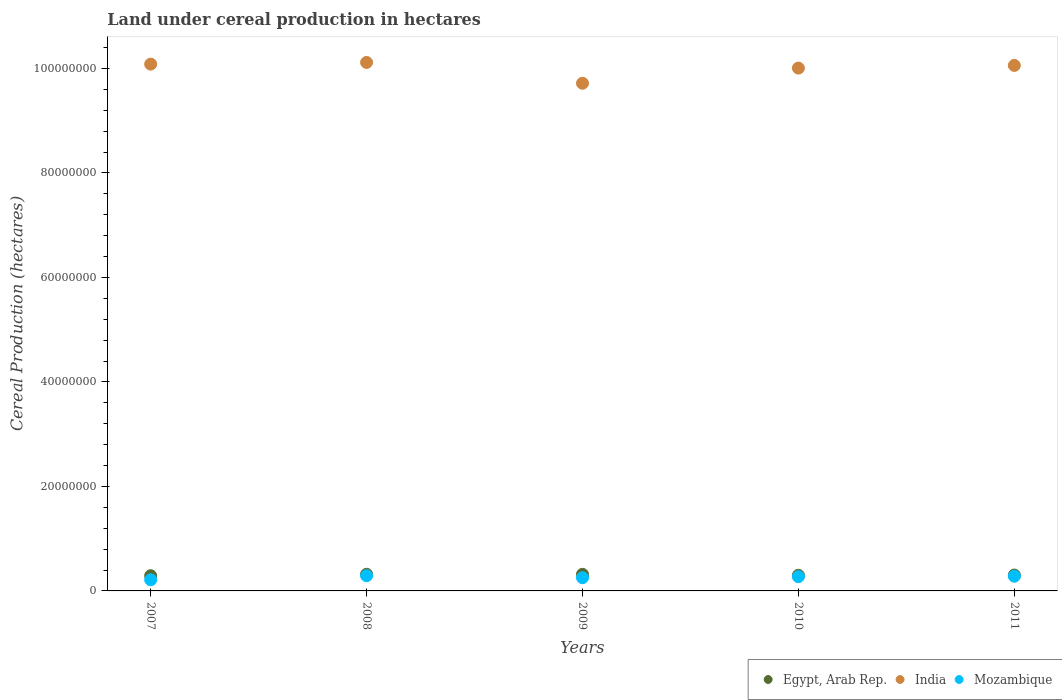What is the land under cereal production in Mozambique in 2008?
Provide a succinct answer. 2.91e+06. Across all years, what is the maximum land under cereal production in Egypt, Arab Rep.?
Offer a terse response. 3.19e+06. Across all years, what is the minimum land under cereal production in India?
Provide a succinct answer. 9.72e+07. In which year was the land under cereal production in India maximum?
Keep it short and to the point. 2008. What is the total land under cereal production in India in the graph?
Ensure brevity in your answer.  5.00e+08. What is the difference between the land under cereal production in Egypt, Arab Rep. in 2007 and that in 2008?
Provide a succinct answer. -2.74e+05. What is the difference between the land under cereal production in Mozambique in 2011 and the land under cereal production in Egypt, Arab Rep. in 2010?
Keep it short and to the point. -1.77e+05. What is the average land under cereal production in India per year?
Your answer should be very brief. 1.00e+08. In the year 2008, what is the difference between the land under cereal production in Egypt, Arab Rep. and land under cereal production in Mozambique?
Give a very brief answer. 2.79e+05. What is the ratio of the land under cereal production in India in 2007 to that in 2011?
Your response must be concise. 1. Is the land under cereal production in Mozambique in 2007 less than that in 2010?
Your answer should be compact. Yes. What is the difference between the highest and the second highest land under cereal production in India?
Your response must be concise. 3.22e+05. What is the difference between the highest and the lowest land under cereal production in Mozambique?
Your answer should be compact. 7.71e+05. In how many years, is the land under cereal production in Mozambique greater than the average land under cereal production in Mozambique taken over all years?
Give a very brief answer. 3. Is the sum of the land under cereal production in India in 2008 and 2010 greater than the maximum land under cereal production in Mozambique across all years?
Your answer should be very brief. Yes. Is it the case that in every year, the sum of the land under cereal production in Mozambique and land under cereal production in India  is greater than the land under cereal production in Egypt, Arab Rep.?
Your answer should be compact. Yes. Is the land under cereal production in India strictly greater than the land under cereal production in Mozambique over the years?
Keep it short and to the point. Yes. Is the land under cereal production in India strictly less than the land under cereal production in Mozambique over the years?
Keep it short and to the point. No. How many years are there in the graph?
Offer a terse response. 5. What is the difference between two consecutive major ticks on the Y-axis?
Keep it short and to the point. 2.00e+07. Where does the legend appear in the graph?
Give a very brief answer. Bottom right. What is the title of the graph?
Your response must be concise. Land under cereal production in hectares. Does "Isle of Man" appear as one of the legend labels in the graph?
Your response must be concise. No. What is the label or title of the Y-axis?
Make the answer very short. Cereal Production (hectares). What is the Cereal Production (hectares) of Egypt, Arab Rep. in 2007?
Provide a short and direct response. 2.91e+06. What is the Cereal Production (hectares) of India in 2007?
Make the answer very short. 1.01e+08. What is the Cereal Production (hectares) in Mozambique in 2007?
Your answer should be very brief. 2.14e+06. What is the Cereal Production (hectares) of Egypt, Arab Rep. in 2008?
Your response must be concise. 3.19e+06. What is the Cereal Production (hectares) in India in 2008?
Offer a very short reply. 1.01e+08. What is the Cereal Production (hectares) in Mozambique in 2008?
Your answer should be compact. 2.91e+06. What is the Cereal Production (hectares) of Egypt, Arab Rep. in 2009?
Your answer should be very brief. 3.18e+06. What is the Cereal Production (hectares) in India in 2009?
Your answer should be compact. 9.72e+07. What is the Cereal Production (hectares) in Mozambique in 2009?
Keep it short and to the point. 2.53e+06. What is the Cereal Production (hectares) of Egypt, Arab Rep. in 2010?
Keep it short and to the point. 2.99e+06. What is the Cereal Production (hectares) of India in 2010?
Offer a very short reply. 1.00e+08. What is the Cereal Production (hectares) of Mozambique in 2010?
Make the answer very short. 2.73e+06. What is the Cereal Production (hectares) of Egypt, Arab Rep. in 2011?
Offer a very short reply. 3.04e+06. What is the Cereal Production (hectares) of India in 2011?
Your answer should be compact. 1.01e+08. What is the Cereal Production (hectares) of Mozambique in 2011?
Ensure brevity in your answer.  2.82e+06. Across all years, what is the maximum Cereal Production (hectares) of Egypt, Arab Rep.?
Keep it short and to the point. 3.19e+06. Across all years, what is the maximum Cereal Production (hectares) in India?
Provide a succinct answer. 1.01e+08. Across all years, what is the maximum Cereal Production (hectares) in Mozambique?
Your answer should be very brief. 2.91e+06. Across all years, what is the minimum Cereal Production (hectares) of Egypt, Arab Rep.?
Keep it short and to the point. 2.91e+06. Across all years, what is the minimum Cereal Production (hectares) in India?
Offer a very short reply. 9.72e+07. Across all years, what is the minimum Cereal Production (hectares) in Mozambique?
Your response must be concise. 2.14e+06. What is the total Cereal Production (hectares) of Egypt, Arab Rep. in the graph?
Offer a very short reply. 1.53e+07. What is the total Cereal Production (hectares) in India in the graph?
Provide a short and direct response. 5.00e+08. What is the total Cereal Production (hectares) of Mozambique in the graph?
Offer a terse response. 1.31e+07. What is the difference between the Cereal Production (hectares) in Egypt, Arab Rep. in 2007 and that in 2008?
Provide a succinct answer. -2.74e+05. What is the difference between the Cereal Production (hectares) of India in 2007 and that in 2008?
Make the answer very short. -3.22e+05. What is the difference between the Cereal Production (hectares) in Mozambique in 2007 and that in 2008?
Give a very brief answer. -7.71e+05. What is the difference between the Cereal Production (hectares) in Egypt, Arab Rep. in 2007 and that in 2009?
Keep it short and to the point. -2.68e+05. What is the difference between the Cereal Production (hectares) in India in 2007 and that in 2009?
Keep it short and to the point. 3.66e+06. What is the difference between the Cereal Production (hectares) of Mozambique in 2007 and that in 2009?
Your response must be concise. -3.96e+05. What is the difference between the Cereal Production (hectares) in Egypt, Arab Rep. in 2007 and that in 2010?
Your answer should be very brief. -8.10e+04. What is the difference between the Cereal Production (hectares) of India in 2007 and that in 2010?
Your response must be concise. 7.58e+05. What is the difference between the Cereal Production (hectares) in Mozambique in 2007 and that in 2010?
Your response must be concise. -5.89e+05. What is the difference between the Cereal Production (hectares) in Egypt, Arab Rep. in 2007 and that in 2011?
Your answer should be very brief. -1.26e+05. What is the difference between the Cereal Production (hectares) of India in 2007 and that in 2011?
Provide a succinct answer. 2.48e+05. What is the difference between the Cereal Production (hectares) of Mozambique in 2007 and that in 2011?
Give a very brief answer. -6.80e+05. What is the difference between the Cereal Production (hectares) in Egypt, Arab Rep. in 2008 and that in 2009?
Offer a very short reply. 6956. What is the difference between the Cereal Production (hectares) in India in 2008 and that in 2009?
Ensure brevity in your answer.  3.98e+06. What is the difference between the Cereal Production (hectares) in Mozambique in 2008 and that in 2009?
Your response must be concise. 3.75e+05. What is the difference between the Cereal Production (hectares) of Egypt, Arab Rep. in 2008 and that in 2010?
Your answer should be compact. 1.93e+05. What is the difference between the Cereal Production (hectares) in India in 2008 and that in 2010?
Offer a terse response. 1.08e+06. What is the difference between the Cereal Production (hectares) of Mozambique in 2008 and that in 2010?
Provide a short and direct response. 1.82e+05. What is the difference between the Cereal Production (hectares) of Egypt, Arab Rep. in 2008 and that in 2011?
Offer a terse response. 1.48e+05. What is the difference between the Cereal Production (hectares) of India in 2008 and that in 2011?
Offer a very short reply. 5.70e+05. What is the difference between the Cereal Production (hectares) in Mozambique in 2008 and that in 2011?
Offer a terse response. 9.06e+04. What is the difference between the Cereal Production (hectares) of Egypt, Arab Rep. in 2009 and that in 2010?
Your answer should be compact. 1.86e+05. What is the difference between the Cereal Production (hectares) in India in 2009 and that in 2010?
Your answer should be very brief. -2.90e+06. What is the difference between the Cereal Production (hectares) of Mozambique in 2009 and that in 2010?
Keep it short and to the point. -1.93e+05. What is the difference between the Cereal Production (hectares) in Egypt, Arab Rep. in 2009 and that in 2011?
Your response must be concise. 1.41e+05. What is the difference between the Cereal Production (hectares) of India in 2009 and that in 2011?
Make the answer very short. -3.41e+06. What is the difference between the Cereal Production (hectares) in Mozambique in 2009 and that in 2011?
Offer a very short reply. -2.84e+05. What is the difference between the Cereal Production (hectares) in Egypt, Arab Rep. in 2010 and that in 2011?
Offer a terse response. -4.52e+04. What is the difference between the Cereal Production (hectares) of India in 2010 and that in 2011?
Ensure brevity in your answer.  -5.10e+05. What is the difference between the Cereal Production (hectares) of Mozambique in 2010 and that in 2011?
Provide a succinct answer. -9.09e+04. What is the difference between the Cereal Production (hectares) in Egypt, Arab Rep. in 2007 and the Cereal Production (hectares) in India in 2008?
Ensure brevity in your answer.  -9.82e+07. What is the difference between the Cereal Production (hectares) of Egypt, Arab Rep. in 2007 and the Cereal Production (hectares) of Mozambique in 2008?
Provide a short and direct response. 4843. What is the difference between the Cereal Production (hectares) of India in 2007 and the Cereal Production (hectares) of Mozambique in 2008?
Ensure brevity in your answer.  9.79e+07. What is the difference between the Cereal Production (hectares) in Egypt, Arab Rep. in 2007 and the Cereal Production (hectares) in India in 2009?
Offer a very short reply. -9.43e+07. What is the difference between the Cereal Production (hectares) of Egypt, Arab Rep. in 2007 and the Cereal Production (hectares) of Mozambique in 2009?
Your answer should be very brief. 3.80e+05. What is the difference between the Cereal Production (hectares) in India in 2007 and the Cereal Production (hectares) in Mozambique in 2009?
Provide a short and direct response. 9.83e+07. What is the difference between the Cereal Production (hectares) in Egypt, Arab Rep. in 2007 and the Cereal Production (hectares) in India in 2010?
Keep it short and to the point. -9.72e+07. What is the difference between the Cereal Production (hectares) in Egypt, Arab Rep. in 2007 and the Cereal Production (hectares) in Mozambique in 2010?
Your answer should be very brief. 1.86e+05. What is the difference between the Cereal Production (hectares) of India in 2007 and the Cereal Production (hectares) of Mozambique in 2010?
Provide a succinct answer. 9.81e+07. What is the difference between the Cereal Production (hectares) in Egypt, Arab Rep. in 2007 and the Cereal Production (hectares) in India in 2011?
Your answer should be very brief. -9.77e+07. What is the difference between the Cereal Production (hectares) in Egypt, Arab Rep. in 2007 and the Cereal Production (hectares) in Mozambique in 2011?
Offer a terse response. 9.55e+04. What is the difference between the Cereal Production (hectares) of India in 2007 and the Cereal Production (hectares) of Mozambique in 2011?
Ensure brevity in your answer.  9.80e+07. What is the difference between the Cereal Production (hectares) in Egypt, Arab Rep. in 2008 and the Cereal Production (hectares) in India in 2009?
Provide a short and direct response. -9.40e+07. What is the difference between the Cereal Production (hectares) of Egypt, Arab Rep. in 2008 and the Cereal Production (hectares) of Mozambique in 2009?
Give a very brief answer. 6.54e+05. What is the difference between the Cereal Production (hectares) in India in 2008 and the Cereal Production (hectares) in Mozambique in 2009?
Offer a very short reply. 9.86e+07. What is the difference between the Cereal Production (hectares) of Egypt, Arab Rep. in 2008 and the Cereal Production (hectares) of India in 2010?
Keep it short and to the point. -9.69e+07. What is the difference between the Cereal Production (hectares) in Egypt, Arab Rep. in 2008 and the Cereal Production (hectares) in Mozambique in 2010?
Your answer should be compact. 4.61e+05. What is the difference between the Cereal Production (hectares) of India in 2008 and the Cereal Production (hectares) of Mozambique in 2010?
Give a very brief answer. 9.84e+07. What is the difference between the Cereal Production (hectares) in Egypt, Arab Rep. in 2008 and the Cereal Production (hectares) in India in 2011?
Give a very brief answer. -9.74e+07. What is the difference between the Cereal Production (hectares) of Egypt, Arab Rep. in 2008 and the Cereal Production (hectares) of Mozambique in 2011?
Keep it short and to the point. 3.70e+05. What is the difference between the Cereal Production (hectares) in India in 2008 and the Cereal Production (hectares) in Mozambique in 2011?
Provide a succinct answer. 9.83e+07. What is the difference between the Cereal Production (hectares) in Egypt, Arab Rep. in 2009 and the Cereal Production (hectares) in India in 2010?
Your answer should be very brief. -9.69e+07. What is the difference between the Cereal Production (hectares) of Egypt, Arab Rep. in 2009 and the Cereal Production (hectares) of Mozambique in 2010?
Your answer should be compact. 4.54e+05. What is the difference between the Cereal Production (hectares) of India in 2009 and the Cereal Production (hectares) of Mozambique in 2010?
Offer a very short reply. 9.44e+07. What is the difference between the Cereal Production (hectares) in Egypt, Arab Rep. in 2009 and the Cereal Production (hectares) in India in 2011?
Give a very brief answer. -9.74e+07. What is the difference between the Cereal Production (hectares) in Egypt, Arab Rep. in 2009 and the Cereal Production (hectares) in Mozambique in 2011?
Offer a terse response. 3.63e+05. What is the difference between the Cereal Production (hectares) of India in 2009 and the Cereal Production (hectares) of Mozambique in 2011?
Your response must be concise. 9.44e+07. What is the difference between the Cereal Production (hectares) in Egypt, Arab Rep. in 2010 and the Cereal Production (hectares) in India in 2011?
Make the answer very short. -9.76e+07. What is the difference between the Cereal Production (hectares) of Egypt, Arab Rep. in 2010 and the Cereal Production (hectares) of Mozambique in 2011?
Give a very brief answer. 1.77e+05. What is the difference between the Cereal Production (hectares) in India in 2010 and the Cereal Production (hectares) in Mozambique in 2011?
Provide a short and direct response. 9.73e+07. What is the average Cereal Production (hectares) of Egypt, Arab Rep. per year?
Make the answer very short. 3.06e+06. What is the average Cereal Production (hectares) in India per year?
Offer a terse response. 1.00e+08. What is the average Cereal Production (hectares) of Mozambique per year?
Your answer should be compact. 2.62e+06. In the year 2007, what is the difference between the Cereal Production (hectares) in Egypt, Arab Rep. and Cereal Production (hectares) in India?
Provide a succinct answer. -9.79e+07. In the year 2007, what is the difference between the Cereal Production (hectares) in Egypt, Arab Rep. and Cereal Production (hectares) in Mozambique?
Your response must be concise. 7.76e+05. In the year 2007, what is the difference between the Cereal Production (hectares) in India and Cereal Production (hectares) in Mozambique?
Keep it short and to the point. 9.87e+07. In the year 2008, what is the difference between the Cereal Production (hectares) in Egypt, Arab Rep. and Cereal Production (hectares) in India?
Your answer should be compact. -9.80e+07. In the year 2008, what is the difference between the Cereal Production (hectares) of Egypt, Arab Rep. and Cereal Production (hectares) of Mozambique?
Provide a short and direct response. 2.79e+05. In the year 2008, what is the difference between the Cereal Production (hectares) in India and Cereal Production (hectares) in Mozambique?
Your response must be concise. 9.82e+07. In the year 2009, what is the difference between the Cereal Production (hectares) in Egypt, Arab Rep. and Cereal Production (hectares) in India?
Your answer should be very brief. -9.40e+07. In the year 2009, what is the difference between the Cereal Production (hectares) of Egypt, Arab Rep. and Cereal Production (hectares) of Mozambique?
Keep it short and to the point. 6.47e+05. In the year 2009, what is the difference between the Cereal Production (hectares) in India and Cereal Production (hectares) in Mozambique?
Offer a terse response. 9.46e+07. In the year 2010, what is the difference between the Cereal Production (hectares) of Egypt, Arab Rep. and Cereal Production (hectares) of India?
Offer a terse response. -9.71e+07. In the year 2010, what is the difference between the Cereal Production (hectares) in Egypt, Arab Rep. and Cereal Production (hectares) in Mozambique?
Provide a short and direct response. 2.67e+05. In the year 2010, what is the difference between the Cereal Production (hectares) of India and Cereal Production (hectares) of Mozambique?
Your answer should be compact. 9.74e+07. In the year 2011, what is the difference between the Cereal Production (hectares) in Egypt, Arab Rep. and Cereal Production (hectares) in India?
Keep it short and to the point. -9.75e+07. In the year 2011, what is the difference between the Cereal Production (hectares) of Egypt, Arab Rep. and Cereal Production (hectares) of Mozambique?
Make the answer very short. 2.22e+05. In the year 2011, what is the difference between the Cereal Production (hectares) of India and Cereal Production (hectares) of Mozambique?
Ensure brevity in your answer.  9.78e+07. What is the ratio of the Cereal Production (hectares) of Egypt, Arab Rep. in 2007 to that in 2008?
Offer a very short reply. 0.91. What is the ratio of the Cereal Production (hectares) of Mozambique in 2007 to that in 2008?
Your answer should be very brief. 0.73. What is the ratio of the Cereal Production (hectares) of Egypt, Arab Rep. in 2007 to that in 2009?
Your answer should be compact. 0.92. What is the ratio of the Cereal Production (hectares) in India in 2007 to that in 2009?
Offer a very short reply. 1.04. What is the ratio of the Cereal Production (hectares) of Mozambique in 2007 to that in 2009?
Ensure brevity in your answer.  0.84. What is the ratio of the Cereal Production (hectares) of Egypt, Arab Rep. in 2007 to that in 2010?
Offer a very short reply. 0.97. What is the ratio of the Cereal Production (hectares) in India in 2007 to that in 2010?
Keep it short and to the point. 1.01. What is the ratio of the Cereal Production (hectares) in Mozambique in 2007 to that in 2010?
Your answer should be very brief. 0.78. What is the ratio of the Cereal Production (hectares) of Egypt, Arab Rep. in 2007 to that in 2011?
Provide a short and direct response. 0.96. What is the ratio of the Cereal Production (hectares) in India in 2007 to that in 2011?
Offer a terse response. 1. What is the ratio of the Cereal Production (hectares) of Mozambique in 2007 to that in 2011?
Offer a very short reply. 0.76. What is the ratio of the Cereal Production (hectares) of Egypt, Arab Rep. in 2008 to that in 2009?
Offer a very short reply. 1. What is the ratio of the Cereal Production (hectares) in India in 2008 to that in 2009?
Give a very brief answer. 1.04. What is the ratio of the Cereal Production (hectares) in Mozambique in 2008 to that in 2009?
Ensure brevity in your answer.  1.15. What is the ratio of the Cereal Production (hectares) of Egypt, Arab Rep. in 2008 to that in 2010?
Your response must be concise. 1.06. What is the ratio of the Cereal Production (hectares) in India in 2008 to that in 2010?
Your answer should be compact. 1.01. What is the ratio of the Cereal Production (hectares) in Mozambique in 2008 to that in 2010?
Provide a succinct answer. 1.07. What is the ratio of the Cereal Production (hectares) of Egypt, Arab Rep. in 2008 to that in 2011?
Ensure brevity in your answer.  1.05. What is the ratio of the Cereal Production (hectares) of India in 2008 to that in 2011?
Your answer should be compact. 1.01. What is the ratio of the Cereal Production (hectares) in Mozambique in 2008 to that in 2011?
Make the answer very short. 1.03. What is the ratio of the Cereal Production (hectares) in Egypt, Arab Rep. in 2009 to that in 2010?
Provide a succinct answer. 1.06. What is the ratio of the Cereal Production (hectares) in Mozambique in 2009 to that in 2010?
Your answer should be very brief. 0.93. What is the ratio of the Cereal Production (hectares) in Egypt, Arab Rep. in 2009 to that in 2011?
Your response must be concise. 1.05. What is the ratio of the Cereal Production (hectares) of India in 2009 to that in 2011?
Keep it short and to the point. 0.97. What is the ratio of the Cereal Production (hectares) in Mozambique in 2009 to that in 2011?
Provide a succinct answer. 0.9. What is the ratio of the Cereal Production (hectares) in Egypt, Arab Rep. in 2010 to that in 2011?
Your answer should be compact. 0.99. What is the ratio of the Cereal Production (hectares) of India in 2010 to that in 2011?
Provide a succinct answer. 0.99. What is the difference between the highest and the second highest Cereal Production (hectares) of Egypt, Arab Rep.?
Your answer should be compact. 6956. What is the difference between the highest and the second highest Cereal Production (hectares) in India?
Offer a terse response. 3.22e+05. What is the difference between the highest and the second highest Cereal Production (hectares) of Mozambique?
Your answer should be compact. 9.06e+04. What is the difference between the highest and the lowest Cereal Production (hectares) of Egypt, Arab Rep.?
Offer a terse response. 2.74e+05. What is the difference between the highest and the lowest Cereal Production (hectares) in India?
Ensure brevity in your answer.  3.98e+06. What is the difference between the highest and the lowest Cereal Production (hectares) of Mozambique?
Provide a short and direct response. 7.71e+05. 